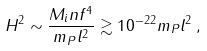<formula> <loc_0><loc_0><loc_500><loc_500>H ^ { 2 } \sim \frac { M _ { i } n f ^ { 4 } } { m _ { P } l ^ { 2 } } \gtrsim 1 0 ^ { - 2 2 } m _ { P } l ^ { 2 } \, ,</formula> 